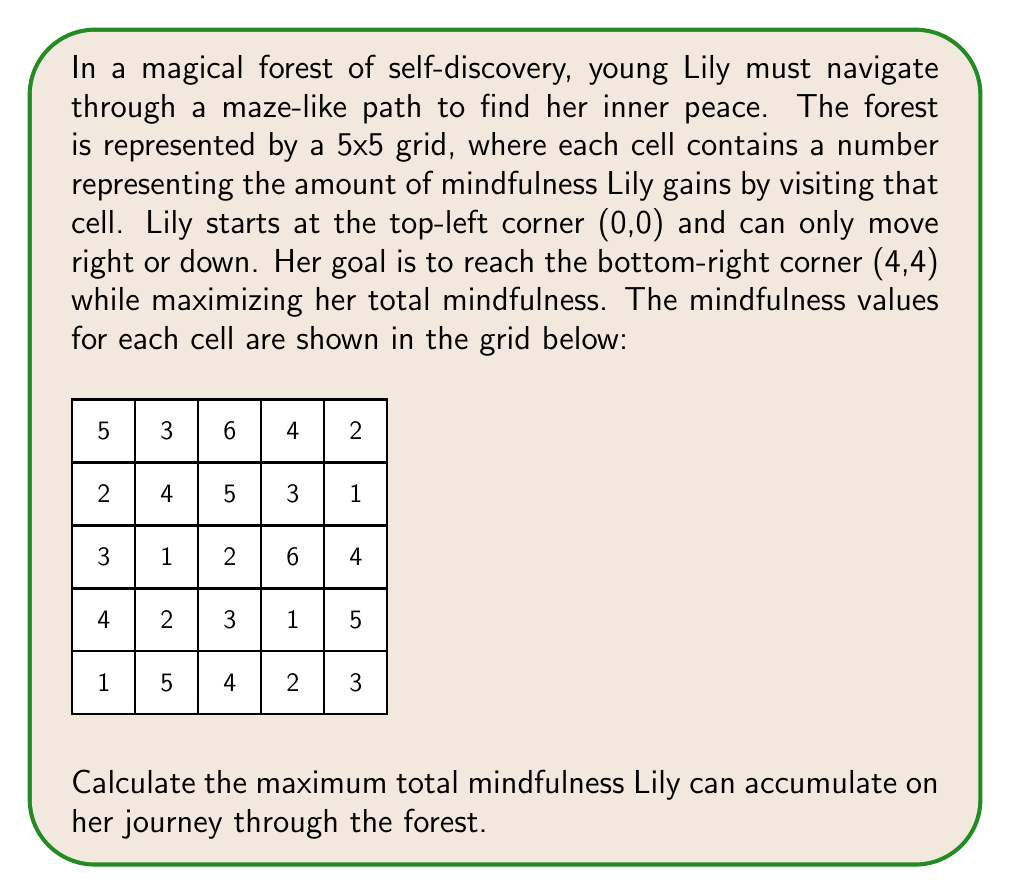Can you solve this math problem? To solve this problem, we'll use dynamic programming to find the optimal path that maximizes Lily's total mindfulness. We'll create a 5x5 matrix to store the maximum mindfulness achievable at each cell.

Let's denote our dynamic programming matrix as $DP[i][j]$, where $i$ and $j$ are the row and column indices respectively.

Step 1: Initialize the DP matrix with the given mindfulness values.

Step 2: Fill the first row and first column of the DP matrix, as there's only one way to reach these cells.
For the first row: $DP[0][j] = DP[0][j-1] + \text{cell value}$ for $j > 0$
For the first column: $DP[i][0] = DP[i-1][0] + \text{cell value}$ for $i > 0$

Step 3: Fill the rest of the DP matrix using the recurrence relation:
$DP[i][j] = \max(DP[i-1][j], DP[i][j-1]) + \text{cell value}$

Step 4: The value in $DP[4][4]$ will give us the maximum total mindfulness.

Let's fill the DP matrix:

$$
\begin{array}{c|ccccc}
DP & 0 & 1 & 2 & 3 & 4 \\
\hline
0 & 5 & 8 & 14 & 18 & 20 \\
1 & 7 & 12 & 19 & 22 & 23 \\
2 & 10 & 13 & 21 & 28 & 32 \\
3 & 14 & 16 & 24 & 29 & 34 \\
4 & 15 & 21 & 28 & 31 & 37
\end{array}
$$

Therefore, the maximum total mindfulness Lily can accumulate is 37.

The optimal path can be traced backwards from $DP[4][4]$ to $DP[0][0]$ by choosing the larger value between the cell above and the cell to the left at each step.
Answer: 37 